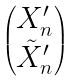<formula> <loc_0><loc_0><loc_500><loc_500>\begin{pmatrix} X ^ { \prime } _ { n } \\ \tilde { X } ^ { \prime } _ { n } \end{pmatrix}</formula> 